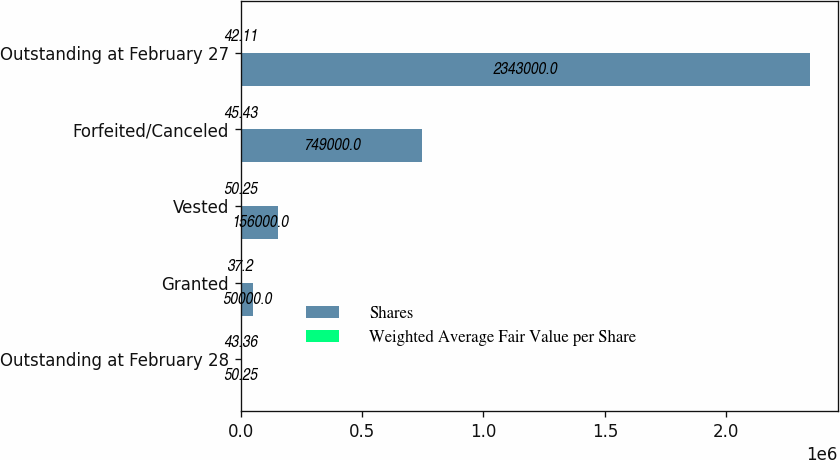Convert chart. <chart><loc_0><loc_0><loc_500><loc_500><stacked_bar_chart><ecel><fcel>Outstanding at February 28<fcel>Granted<fcel>Vested<fcel>Forfeited/Canceled<fcel>Outstanding at February 27<nl><fcel>Shares<fcel>50.25<fcel>50000<fcel>156000<fcel>749000<fcel>2.343e+06<nl><fcel>Weighted Average Fair Value per Share<fcel>43.36<fcel>37.2<fcel>50.25<fcel>45.43<fcel>42.11<nl></chart> 